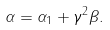Convert formula to latex. <formula><loc_0><loc_0><loc_500><loc_500>\alpha = \alpha _ { 1 } + \gamma ^ { 2 } \beta .</formula> 